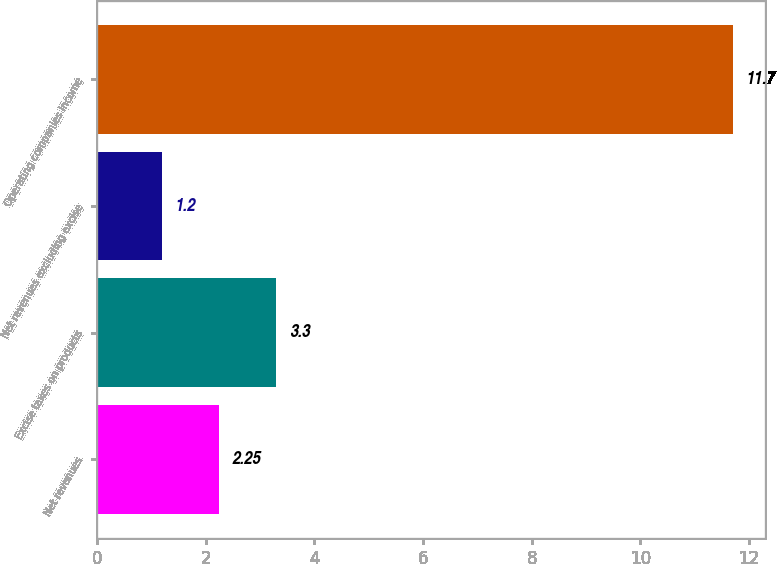<chart> <loc_0><loc_0><loc_500><loc_500><bar_chart><fcel>Net revenues<fcel>Excise taxes on products<fcel>Net revenues excluding excise<fcel>Operating companies income<nl><fcel>2.25<fcel>3.3<fcel>1.2<fcel>11.7<nl></chart> 